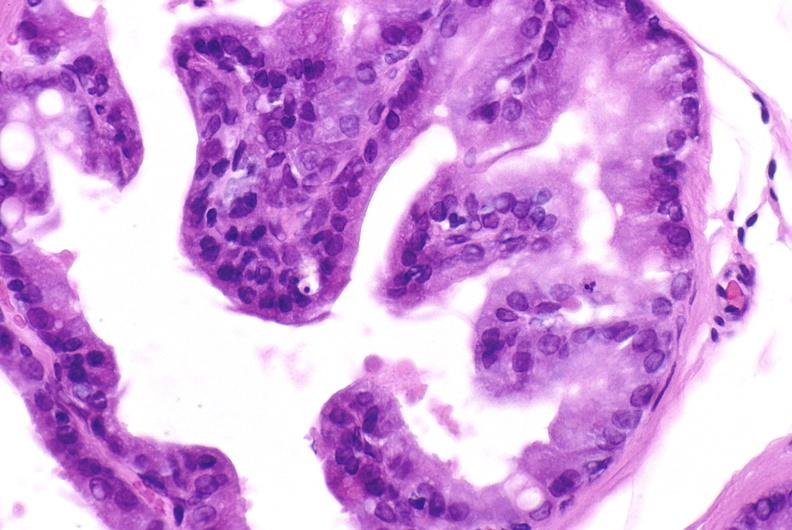does this image show apoptosis in prostate after orchiectomy?
Answer the question using a single word or phrase. Yes 